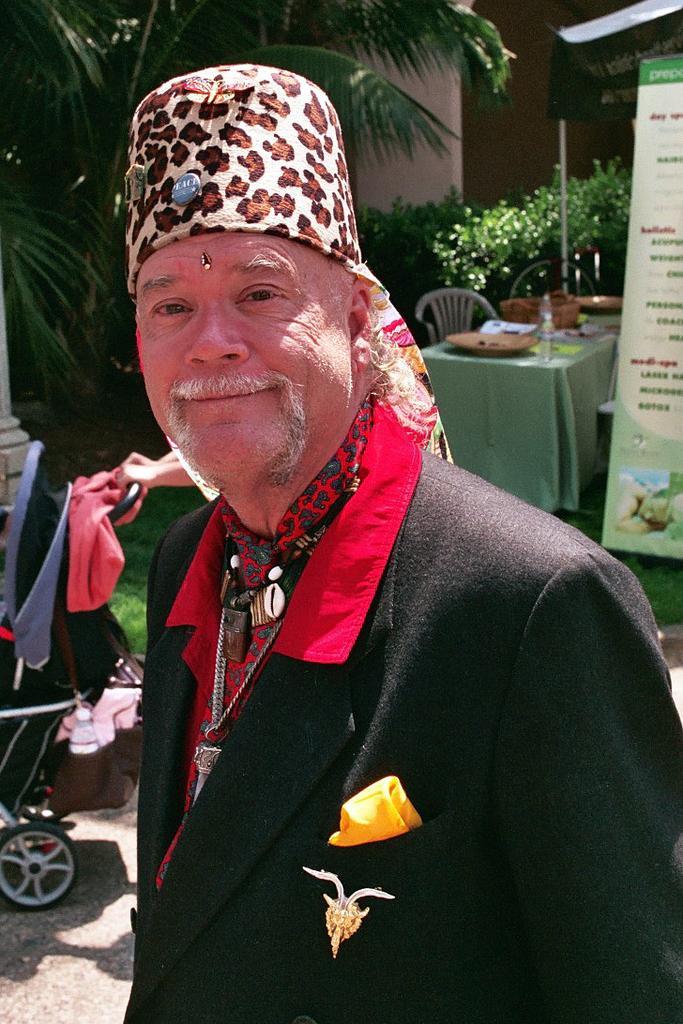In one or two sentences, can you explain what this image depicts? In the image there is a man in the foreground and behind him there is a trolley, table, chair, a board and on the left side there are trees, beside the trees there are plants. 